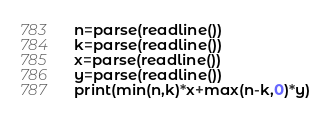Convert code to text. <code><loc_0><loc_0><loc_500><loc_500><_Julia_>n=parse(readline())
k=parse(readline())
x=parse(readline())
y=parse(readline())
print(min(n,k)*x+max(n-k,0)*y)</code> 